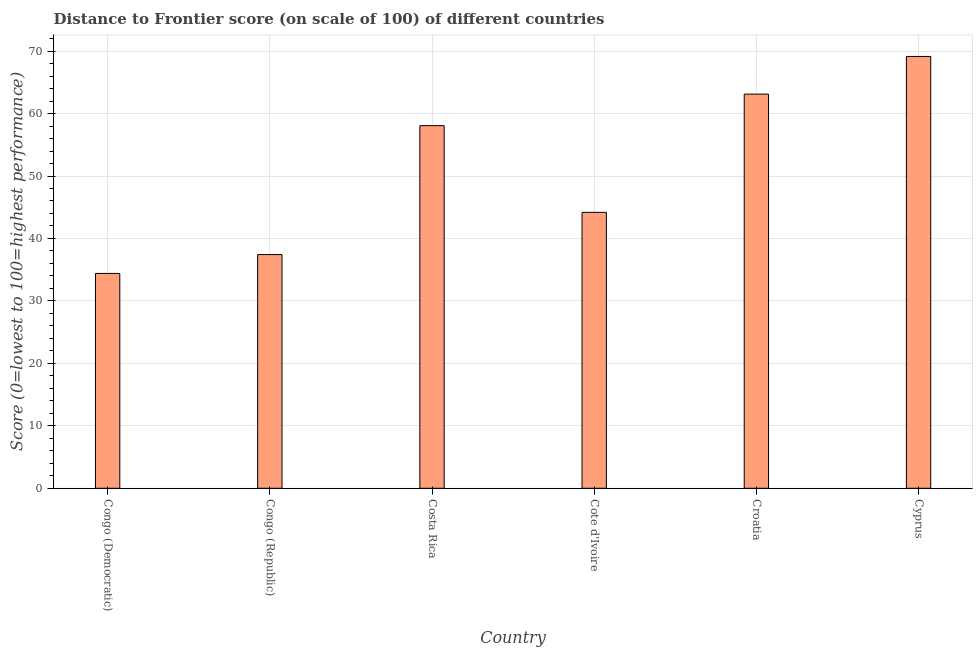Does the graph contain any zero values?
Keep it short and to the point. No. What is the title of the graph?
Keep it short and to the point. Distance to Frontier score (on scale of 100) of different countries. What is the label or title of the X-axis?
Your answer should be compact. Country. What is the label or title of the Y-axis?
Offer a very short reply. Score (0=lowest to 100=highest performance). What is the distance to frontier score in Croatia?
Your response must be concise. 63.11. Across all countries, what is the maximum distance to frontier score?
Your answer should be compact. 69.14. Across all countries, what is the minimum distance to frontier score?
Offer a very short reply. 34.4. In which country was the distance to frontier score maximum?
Make the answer very short. Cyprus. In which country was the distance to frontier score minimum?
Offer a terse response. Congo (Democratic). What is the sum of the distance to frontier score?
Your answer should be very brief. 306.31. What is the difference between the distance to frontier score in Costa Rica and Croatia?
Give a very brief answer. -5.05. What is the average distance to frontier score per country?
Keep it short and to the point. 51.05. What is the median distance to frontier score?
Your response must be concise. 51.12. What is the ratio of the distance to frontier score in Costa Rica to that in Cyprus?
Your answer should be very brief. 0.84. What is the difference between the highest and the second highest distance to frontier score?
Ensure brevity in your answer.  6.03. What is the difference between the highest and the lowest distance to frontier score?
Provide a succinct answer. 34.74. How many countries are there in the graph?
Your answer should be very brief. 6. What is the difference between two consecutive major ticks on the Y-axis?
Provide a short and direct response. 10. Are the values on the major ticks of Y-axis written in scientific E-notation?
Offer a very short reply. No. What is the Score (0=lowest to 100=highest performance) in Congo (Democratic)?
Give a very brief answer. 34.4. What is the Score (0=lowest to 100=highest performance) in Congo (Republic)?
Your answer should be compact. 37.42. What is the Score (0=lowest to 100=highest performance) in Costa Rica?
Provide a short and direct response. 58.06. What is the Score (0=lowest to 100=highest performance) of Cote d'Ivoire?
Make the answer very short. 44.18. What is the Score (0=lowest to 100=highest performance) of Croatia?
Ensure brevity in your answer.  63.11. What is the Score (0=lowest to 100=highest performance) of Cyprus?
Your answer should be compact. 69.14. What is the difference between the Score (0=lowest to 100=highest performance) in Congo (Democratic) and Congo (Republic)?
Offer a terse response. -3.02. What is the difference between the Score (0=lowest to 100=highest performance) in Congo (Democratic) and Costa Rica?
Your answer should be very brief. -23.66. What is the difference between the Score (0=lowest to 100=highest performance) in Congo (Democratic) and Cote d'Ivoire?
Your answer should be very brief. -9.78. What is the difference between the Score (0=lowest to 100=highest performance) in Congo (Democratic) and Croatia?
Offer a very short reply. -28.71. What is the difference between the Score (0=lowest to 100=highest performance) in Congo (Democratic) and Cyprus?
Offer a terse response. -34.74. What is the difference between the Score (0=lowest to 100=highest performance) in Congo (Republic) and Costa Rica?
Make the answer very short. -20.64. What is the difference between the Score (0=lowest to 100=highest performance) in Congo (Republic) and Cote d'Ivoire?
Your answer should be very brief. -6.76. What is the difference between the Score (0=lowest to 100=highest performance) in Congo (Republic) and Croatia?
Give a very brief answer. -25.69. What is the difference between the Score (0=lowest to 100=highest performance) in Congo (Republic) and Cyprus?
Make the answer very short. -31.72. What is the difference between the Score (0=lowest to 100=highest performance) in Costa Rica and Cote d'Ivoire?
Keep it short and to the point. 13.88. What is the difference between the Score (0=lowest to 100=highest performance) in Costa Rica and Croatia?
Your answer should be very brief. -5.05. What is the difference between the Score (0=lowest to 100=highest performance) in Costa Rica and Cyprus?
Ensure brevity in your answer.  -11.08. What is the difference between the Score (0=lowest to 100=highest performance) in Cote d'Ivoire and Croatia?
Make the answer very short. -18.93. What is the difference between the Score (0=lowest to 100=highest performance) in Cote d'Ivoire and Cyprus?
Ensure brevity in your answer.  -24.96. What is the difference between the Score (0=lowest to 100=highest performance) in Croatia and Cyprus?
Your response must be concise. -6.03. What is the ratio of the Score (0=lowest to 100=highest performance) in Congo (Democratic) to that in Congo (Republic)?
Ensure brevity in your answer.  0.92. What is the ratio of the Score (0=lowest to 100=highest performance) in Congo (Democratic) to that in Costa Rica?
Give a very brief answer. 0.59. What is the ratio of the Score (0=lowest to 100=highest performance) in Congo (Democratic) to that in Cote d'Ivoire?
Provide a succinct answer. 0.78. What is the ratio of the Score (0=lowest to 100=highest performance) in Congo (Democratic) to that in Croatia?
Give a very brief answer. 0.55. What is the ratio of the Score (0=lowest to 100=highest performance) in Congo (Democratic) to that in Cyprus?
Your answer should be very brief. 0.5. What is the ratio of the Score (0=lowest to 100=highest performance) in Congo (Republic) to that in Costa Rica?
Keep it short and to the point. 0.65. What is the ratio of the Score (0=lowest to 100=highest performance) in Congo (Republic) to that in Cote d'Ivoire?
Make the answer very short. 0.85. What is the ratio of the Score (0=lowest to 100=highest performance) in Congo (Republic) to that in Croatia?
Your response must be concise. 0.59. What is the ratio of the Score (0=lowest to 100=highest performance) in Congo (Republic) to that in Cyprus?
Your answer should be compact. 0.54. What is the ratio of the Score (0=lowest to 100=highest performance) in Costa Rica to that in Cote d'Ivoire?
Make the answer very short. 1.31. What is the ratio of the Score (0=lowest to 100=highest performance) in Costa Rica to that in Cyprus?
Offer a terse response. 0.84. What is the ratio of the Score (0=lowest to 100=highest performance) in Cote d'Ivoire to that in Croatia?
Make the answer very short. 0.7. What is the ratio of the Score (0=lowest to 100=highest performance) in Cote d'Ivoire to that in Cyprus?
Give a very brief answer. 0.64. 